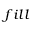<formula> <loc_0><loc_0><loc_500><loc_500>_ { f i l l }</formula> 